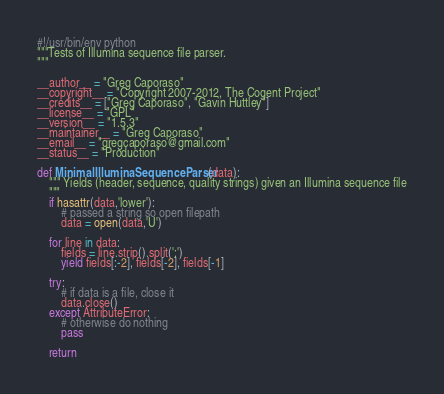<code> <loc_0><loc_0><loc_500><loc_500><_Python_>#!/usr/bin/env python
"""Tests of Illumina sequence file parser.
"""

__author__ = "Greg Caporaso"
__copyright__ = "Copyright 2007-2012, The Cogent Project"
__credits__ = ["Greg Caporaso", "Gavin Huttley"]
__license__ = "GPL"
__version__ = "1.5.3"
__maintainer__ = "Greg Caporaso"
__email__ = "gregcaporaso@gmail.com"
__status__ = "Production"

def MinimalIlluminaSequenceParser(data):
    """ Yields (header, sequence, quality strings) given an Illumina sequence file
    """
    if hasattr(data,'lower'):
        # passed a string so open filepath
        data = open(data,'U')
    
    for line in data:
        fields = line.strip().split(':')
        yield fields[:-2], fields[-2], fields[-1]
    
    try:
        # if data is a file, close it
        data.close()
    except AttributeError:
        # otherwise do nothing
        pass
    
    return
</code> 